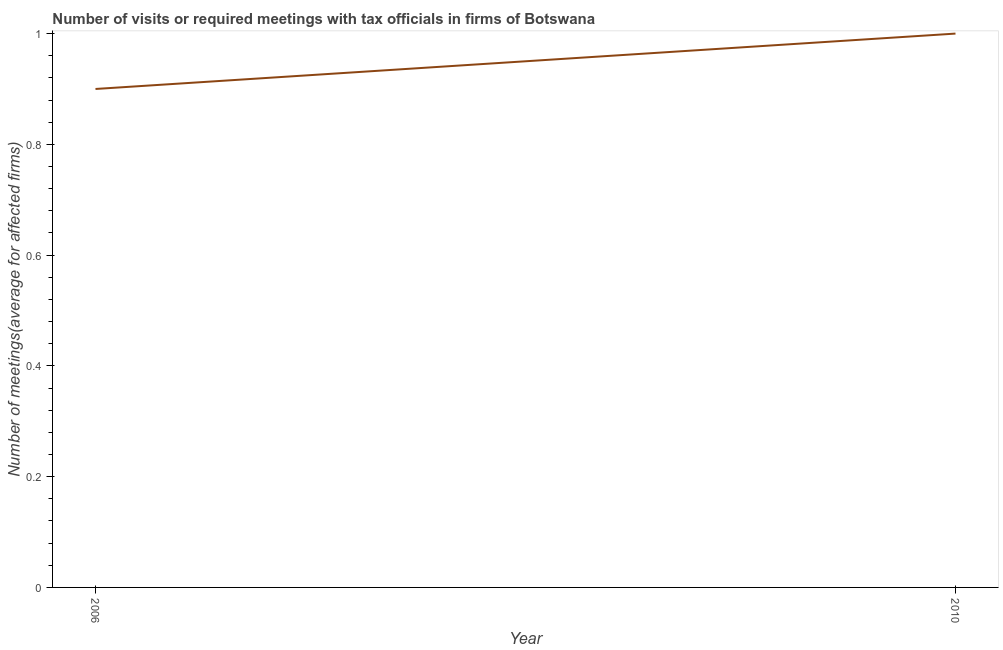What is the number of required meetings with tax officials in 2006?
Offer a very short reply. 0.9. Across all years, what is the maximum number of required meetings with tax officials?
Your answer should be compact. 1. Across all years, what is the minimum number of required meetings with tax officials?
Offer a very short reply. 0.9. In which year was the number of required meetings with tax officials minimum?
Offer a terse response. 2006. What is the sum of the number of required meetings with tax officials?
Your answer should be compact. 1.9. What is the difference between the number of required meetings with tax officials in 2006 and 2010?
Your answer should be compact. -0.1. What is the median number of required meetings with tax officials?
Your answer should be compact. 0.95. In how many years, is the number of required meetings with tax officials greater than 0.8 ?
Provide a succinct answer. 2. Do a majority of the years between 2010 and 2006 (inclusive) have number of required meetings with tax officials greater than 0.8400000000000001 ?
Provide a short and direct response. No. What is the ratio of the number of required meetings with tax officials in 2006 to that in 2010?
Make the answer very short. 0.9. Is the number of required meetings with tax officials in 2006 less than that in 2010?
Your answer should be compact. Yes. In how many years, is the number of required meetings with tax officials greater than the average number of required meetings with tax officials taken over all years?
Your answer should be very brief. 1. Does the number of required meetings with tax officials monotonically increase over the years?
Your answer should be very brief. Yes. How many years are there in the graph?
Ensure brevity in your answer.  2. Are the values on the major ticks of Y-axis written in scientific E-notation?
Offer a very short reply. No. Does the graph contain any zero values?
Offer a terse response. No. Does the graph contain grids?
Your answer should be very brief. No. What is the title of the graph?
Make the answer very short. Number of visits or required meetings with tax officials in firms of Botswana. What is the label or title of the X-axis?
Offer a terse response. Year. What is the label or title of the Y-axis?
Your answer should be compact. Number of meetings(average for affected firms). What is the ratio of the Number of meetings(average for affected firms) in 2006 to that in 2010?
Give a very brief answer. 0.9. 